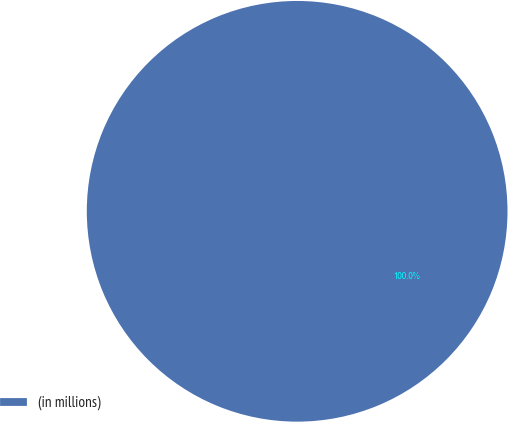<chart> <loc_0><loc_0><loc_500><loc_500><pie_chart><fcel>(in millions)<nl><fcel>100.0%<nl></chart> 